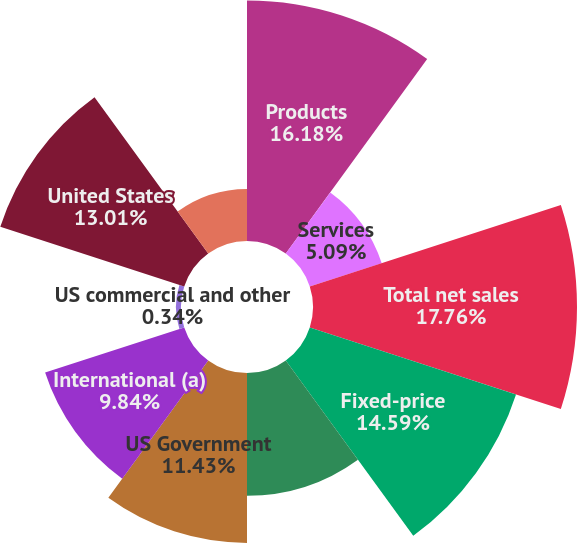Convert chart. <chart><loc_0><loc_0><loc_500><loc_500><pie_chart><fcel>Products<fcel>Services<fcel>Total net sales<fcel>Fixed-price<fcel>Cost-reimbursable<fcel>US Government<fcel>International (a)<fcel>US commercial and other<fcel>United States<fcel>Asia Pacific<nl><fcel>16.18%<fcel>5.09%<fcel>17.76%<fcel>14.59%<fcel>8.26%<fcel>11.43%<fcel>9.84%<fcel>0.34%<fcel>13.01%<fcel>3.5%<nl></chart> 